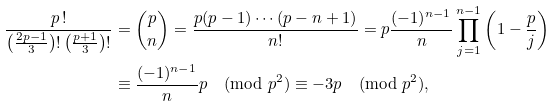<formula> <loc_0><loc_0><loc_500><loc_500>\frac { p \, ! } { \left ( \frac { 2 p - 1 } { 3 } \right ) ! \left ( \frac { p + 1 } { 3 } \right ) ! } & = \binom { p } { n } = \frac { p ( p - 1 ) \cdots ( p - n + 1 ) } { n ! } = p \frac { ( - 1 ) ^ { n - 1 } } { n } \prod _ { j = 1 } ^ { n - 1 } \left ( 1 - \frac { p } { j } \right ) \\ & \equiv \frac { ( - 1 ) ^ { n - 1 } } { n } p \pmod { p ^ { 2 } } \equiv - 3 p \pmod { p ^ { 2 } } ,</formula> 